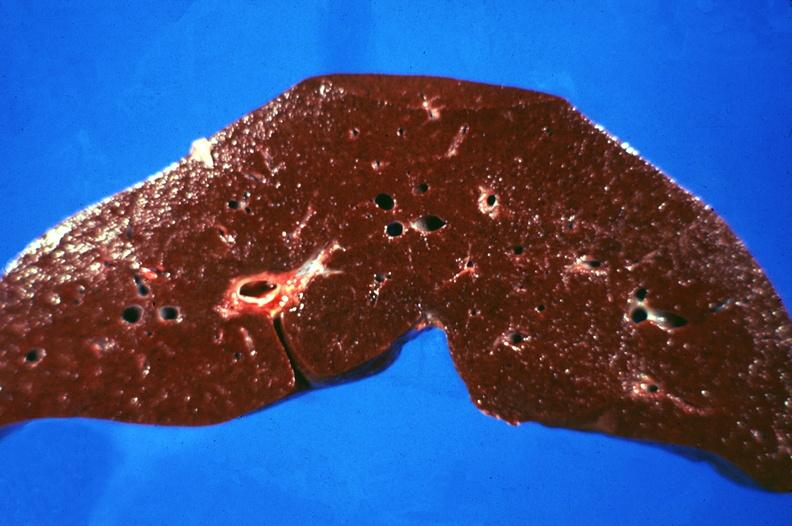does an opened peritoneal cavity cause by fibrous band strangulation show liver, hemochromatosis?
Answer the question using a single word or phrase. No 